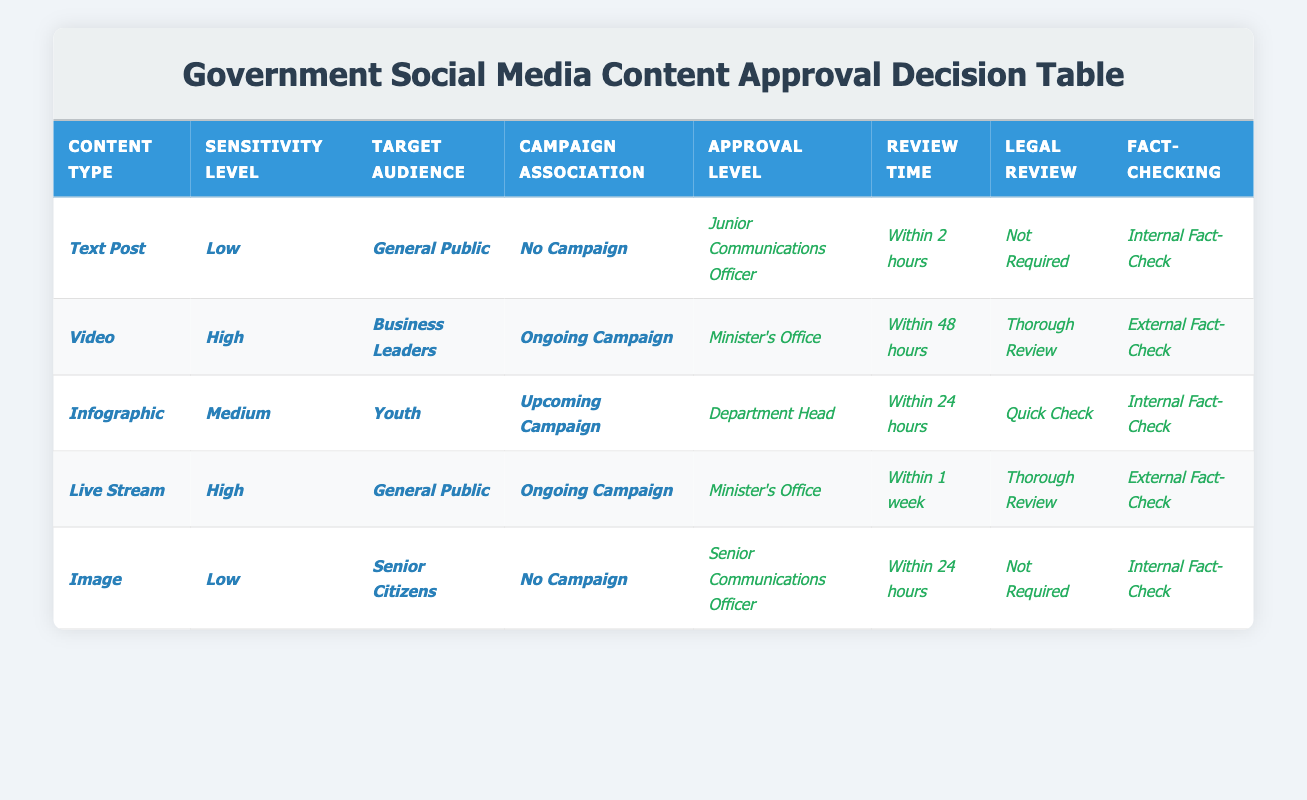What is the approval level for a text post aimed at the general public with low sensitivity? The corresponding row for a text post with low sensitivity aimed at the general public shows that the approval level is "Junior Communications Officer."
Answer: Junior Communications Officer How long does it take to review an infographic targeting youth with medium sensitivity and scheduled for an upcoming campaign? Looking at the row for an infographic with medium sensitivity aimed at youth and associated with an upcoming campaign, it states that the review time is "Within 24 hours."
Answer: Within 24 hours Is a legal review required for images targeting senior citizens with low sensitivity that are not associated with any campaign? By checking the row for images with low sensitivity aimed at senior citizens and not linked to any campaign, it indicates "Not Required" for legal review.
Answer: Not Required What is the fact-checking process involved for live streams with high sensitivity targeting the general public during an ongoing campaign? The row for live streams with high sensitivity aimed at the general public and linked to an ongoing campaign tells us that the fact-checking process involves an "External Fact-Check."
Answer: External Fact-Check Which type of content requires the highest approval level when it has a high sensitivity rating and targets business leaders? The row for video content targeting business leaders with high sensitivity shows that the approval level is at the "Minister's Office," which is indeed the highest.
Answer: Minister's Office What is the average review time for posts requiring a departmental head's approval? There is only one content type that requires approval from a department head, which is the infographic with a review time of "Within 24 hours," leading to an average of 24 hours.
Answer: 24 hours Does a low sensitivity image targeting senior citizens require external fact-checking? Checking the relevant row for low sensitivity images aimed at senior citizens reveals that the fact-checking is done internally rather than externally, hence the answer is no.
Answer: No How many types of content are associated with the Minister's Office for approval? The table displays two types of content associated with the Minister's Office: video and live stream, so adding these together gives us a total of two.
Answer: 2 For which type of content is a thorough legal review required? According to the table, a thorough legal review is required for videos with high sensitivity aimed at business leaders and live streams with high sensitivity aimed at the general public.
Answer: Video and Live Stream 